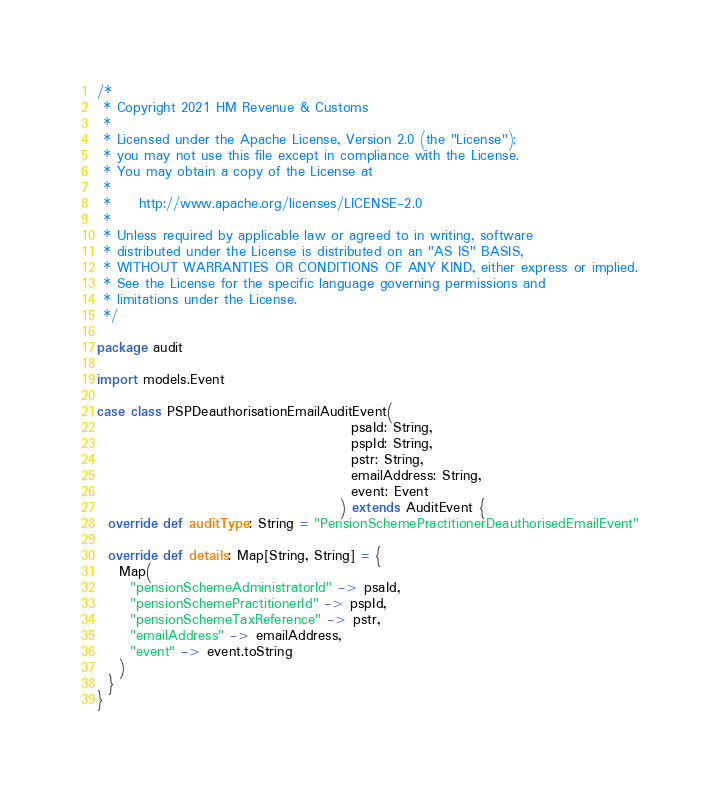Convert code to text. <code><loc_0><loc_0><loc_500><loc_500><_Scala_>/*
 * Copyright 2021 HM Revenue & Customs
 *
 * Licensed under the Apache License, Version 2.0 (the "License");
 * you may not use this file except in compliance with the License.
 * You may obtain a copy of the License at
 *
 *     http://www.apache.org/licenses/LICENSE-2.0
 *
 * Unless required by applicable law or agreed to in writing, software
 * distributed under the License is distributed on an "AS IS" BASIS,
 * WITHOUT WARRANTIES OR CONDITIONS OF ANY KIND, either express or implied.
 * See the License for the specific language governing permissions and
 * limitations under the License.
 */

package audit

import models.Event

case class PSPDeauthorisationEmailAuditEvent(
                                              psaId: String,
                                              pspId: String,
                                              pstr: String,
                                              emailAddress: String,
                                              event: Event
                                            ) extends AuditEvent {
  override def auditType: String = "PensionSchemePractitionerDeauthorisedEmailEvent"

  override def details: Map[String, String] = {
    Map(
      "pensionSchemeAdministratorId" -> psaId,
      "pensionSchemePractitionerId" -> pspId,
      "pensionSchemeTaxReference" -> pstr,
      "emailAddress" -> emailAddress,
      "event" -> event.toString
    )
  }
}
</code> 